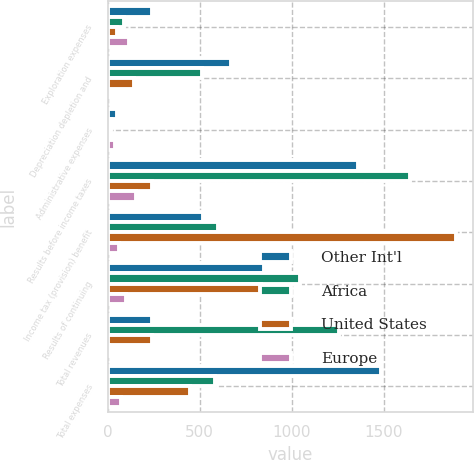<chart> <loc_0><loc_0><loc_500><loc_500><stacked_bar_chart><ecel><fcel>Exploration expenses<fcel>Depreciation depletion and<fcel>Administrative expenses<fcel>Results before income taxes<fcel>Income tax (provision) benefit<fcel>Results of continuing<fcel>Total revenues<fcel>Total expenses<nl><fcel>Other Int'l<fcel>238<fcel>671<fcel>49<fcel>1363<fcel>516<fcel>847<fcel>238<fcel>1488<nl><fcel>Africa<fcel>88<fcel>512<fcel>15<fcel>1641<fcel>598<fcel>1043<fcel>1258<fcel>585<nl><fcel>United States<fcel>47<fcel>144<fcel>5<fcel>238<fcel>1892<fcel>832<fcel>238<fcel>446<nl><fcel>Europe<fcel>117<fcel>1<fcel>37<fcel>155<fcel>58<fcel>97<fcel>7<fcel>71<nl></chart> 